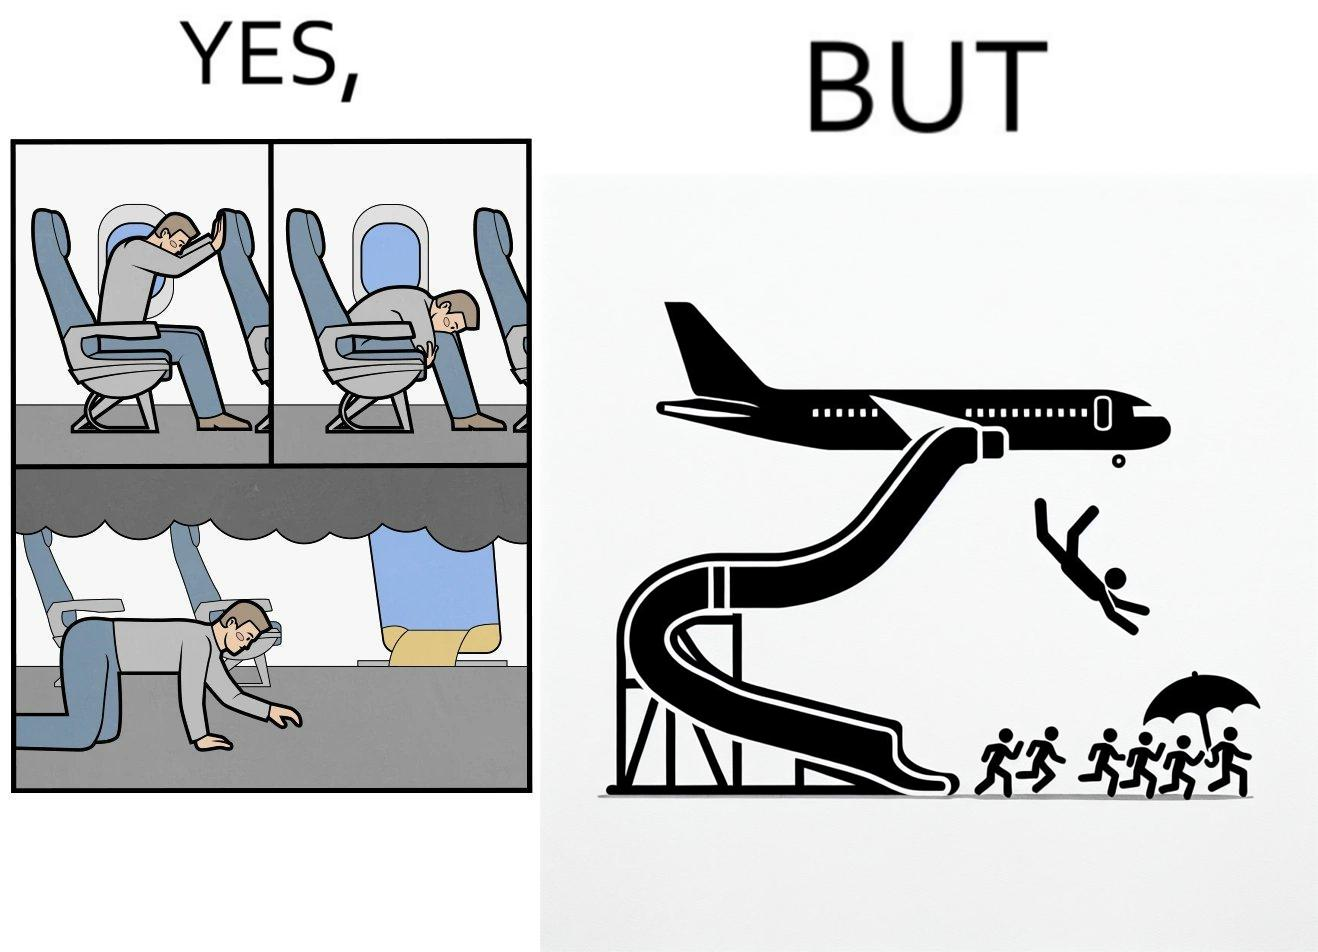Is this a satirical image? Yes, this image is satirical. 